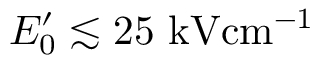<formula> <loc_0><loc_0><loc_500><loc_500>E _ { 0 } ^ { \prime } \lesssim 2 5 { k V c m ^ { - 1 } }</formula> 